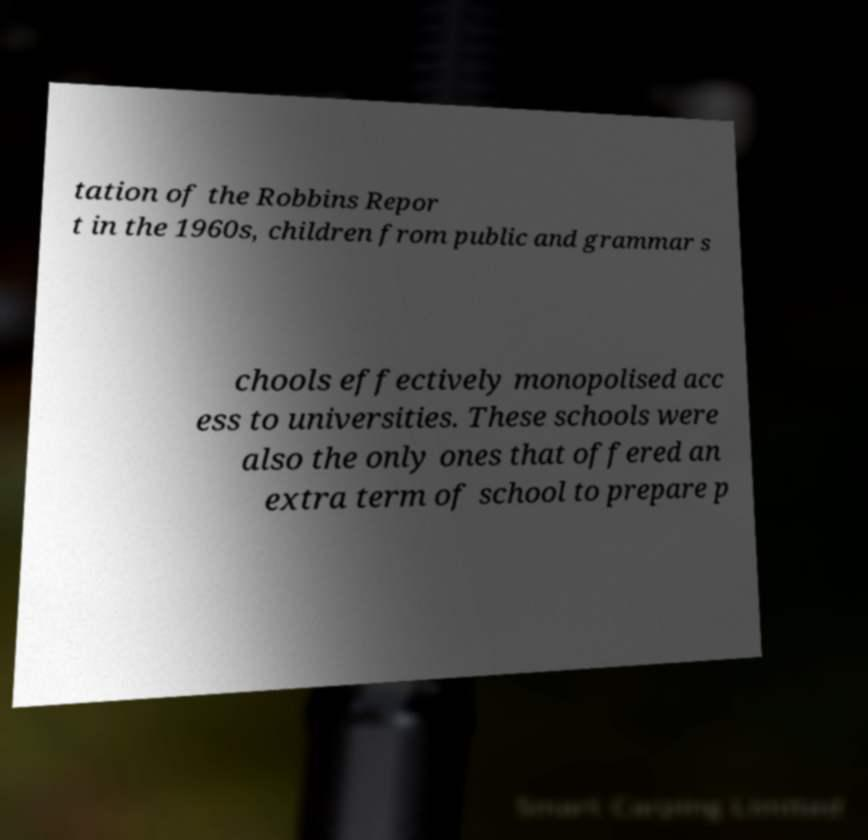Could you assist in decoding the text presented in this image and type it out clearly? tation of the Robbins Repor t in the 1960s, children from public and grammar s chools effectively monopolised acc ess to universities. These schools were also the only ones that offered an extra term of school to prepare p 